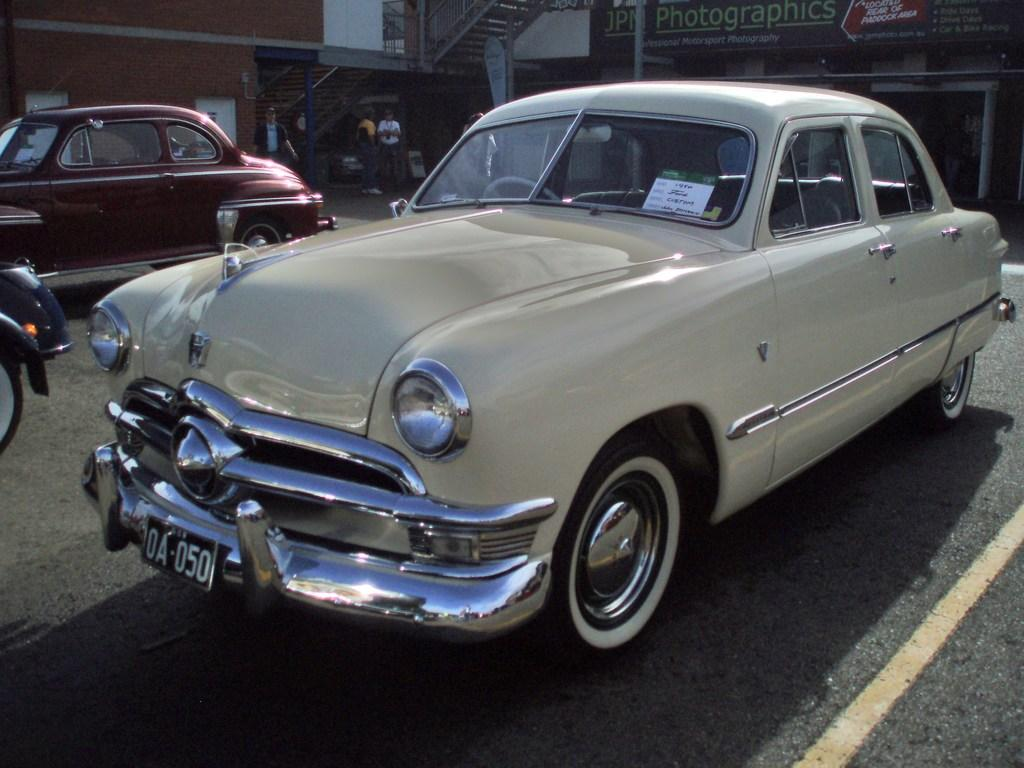What is the main subject in the center of the image? There are vehicles in the center of the image. What is located at the bottom of the image? There is a road at the bottom of the image. What can be seen in the background of the image? There are buildings and people visible in the background of the image. How many feet are visible in the image? There is no specific mention of feet in the image, so it is not possible to determine the number of feet visible. 